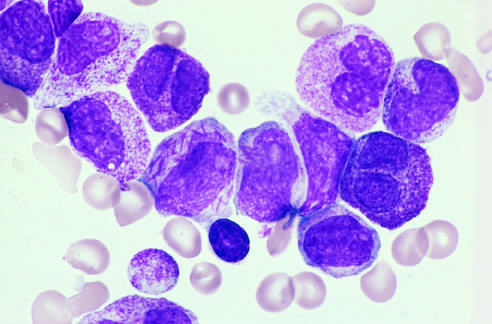do the neo-plastic promyelocytes have abnormally coarse and numerous azurophilic granules?
Answer the question using a single word or phrase. Yes 